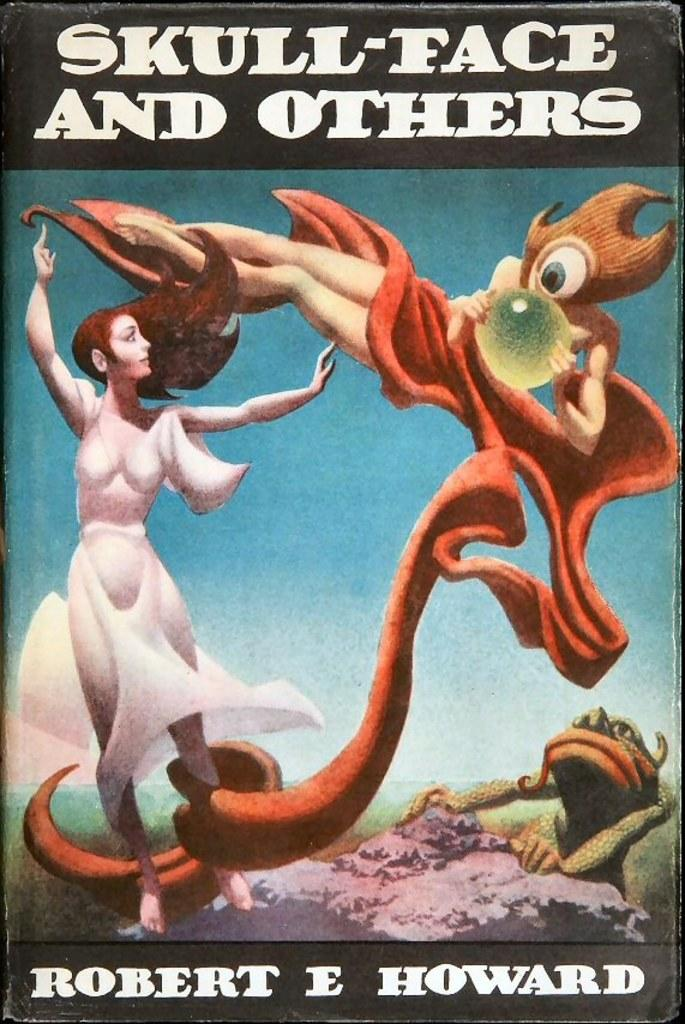<image>
Provide a brief description of the given image. The book shown was written by Robert E Howard. 